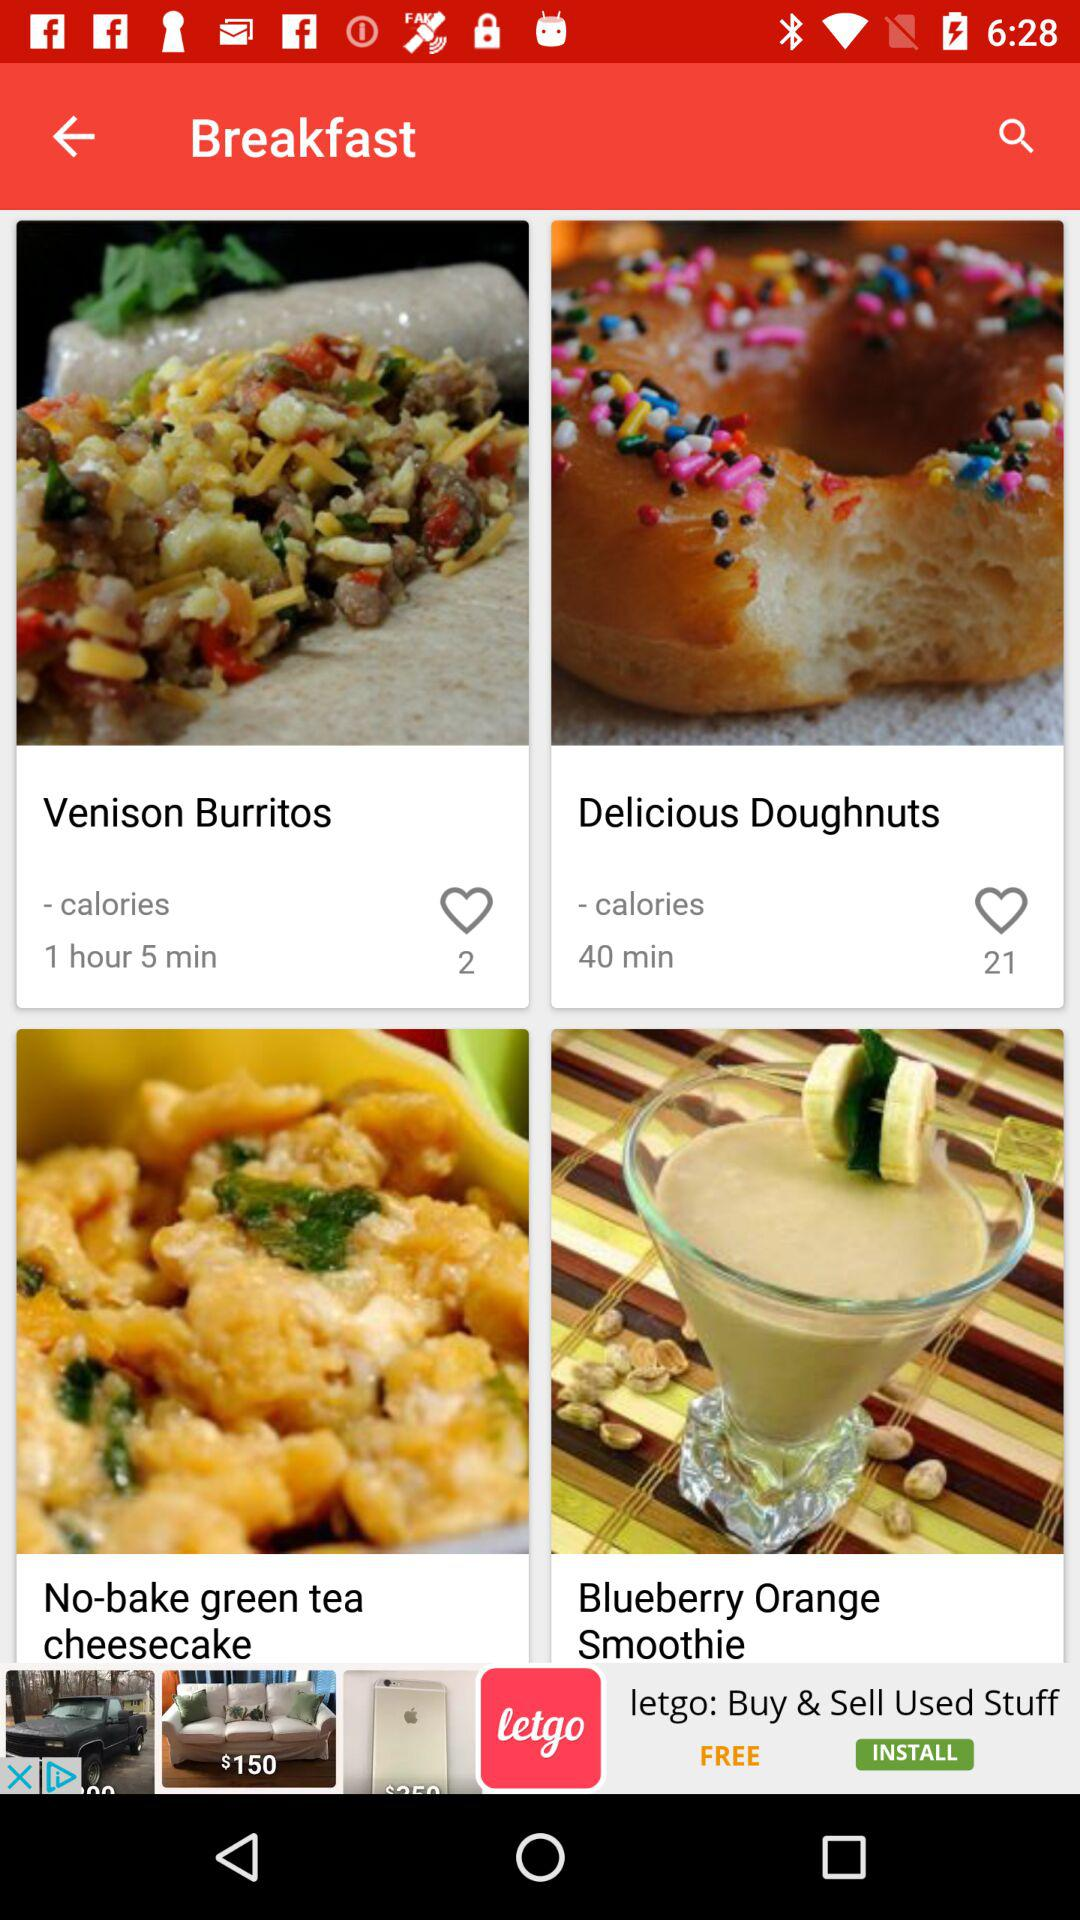Which dish is prepared in 40 minutes? It is Delicious Doughnuts. 